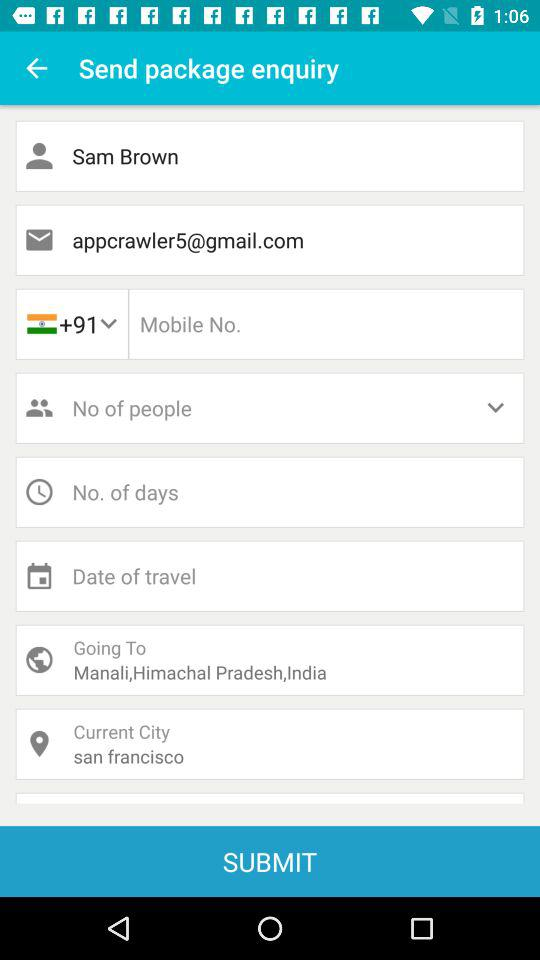What is the current city? The current city is San Francisco. 